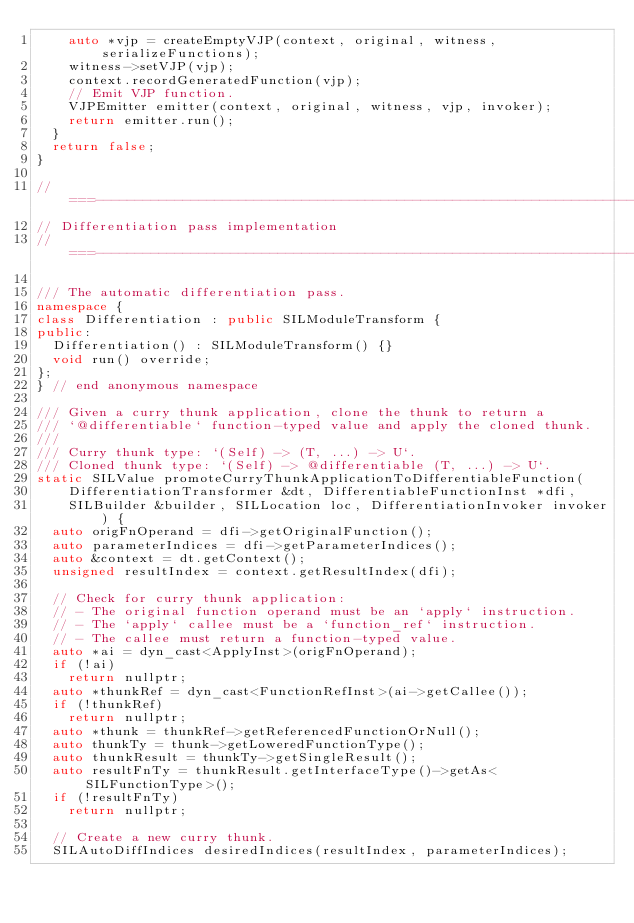Convert code to text. <code><loc_0><loc_0><loc_500><loc_500><_C++_>    auto *vjp = createEmptyVJP(context, original, witness, serializeFunctions);
    witness->setVJP(vjp);
    context.recordGeneratedFunction(vjp);
    // Emit VJP function.
    VJPEmitter emitter(context, original, witness, vjp, invoker);
    return emitter.run();
  }
  return false;
}

//===----------------------------------------------------------------------===//
// Differentiation pass implementation
//===----------------------------------------------------------------------===//

/// The automatic differentiation pass.
namespace {
class Differentiation : public SILModuleTransform {
public:
  Differentiation() : SILModuleTransform() {}
  void run() override;
};
} // end anonymous namespace

/// Given a curry thunk application, clone the thunk to return a
/// `@differentiable` function-typed value and apply the cloned thunk.
///
/// Curry thunk type: `(Self) -> (T, ...) -> U`.
/// Cloned thunk type: `(Self) -> @differentiable (T, ...) -> U`.
static SILValue promoteCurryThunkApplicationToDifferentiableFunction(
    DifferentiationTransformer &dt, DifferentiableFunctionInst *dfi,
    SILBuilder &builder, SILLocation loc, DifferentiationInvoker invoker) {
  auto origFnOperand = dfi->getOriginalFunction();
  auto parameterIndices = dfi->getParameterIndices();
  auto &context = dt.getContext();
  unsigned resultIndex = context.getResultIndex(dfi);

  // Check for curry thunk application:
  // - The original function operand must be an `apply` instruction.
  // - The `apply` callee must be a `function_ref` instruction.
  // - The callee must return a function-typed value.
  auto *ai = dyn_cast<ApplyInst>(origFnOperand);
  if (!ai)
    return nullptr;
  auto *thunkRef = dyn_cast<FunctionRefInst>(ai->getCallee());
  if (!thunkRef)
    return nullptr;
  auto *thunk = thunkRef->getReferencedFunctionOrNull();
  auto thunkTy = thunk->getLoweredFunctionType();
  auto thunkResult = thunkTy->getSingleResult();
  auto resultFnTy = thunkResult.getInterfaceType()->getAs<SILFunctionType>();
  if (!resultFnTy)
    return nullptr;

  // Create a new curry thunk.
  SILAutoDiffIndices desiredIndices(resultIndex, parameterIndices);</code> 